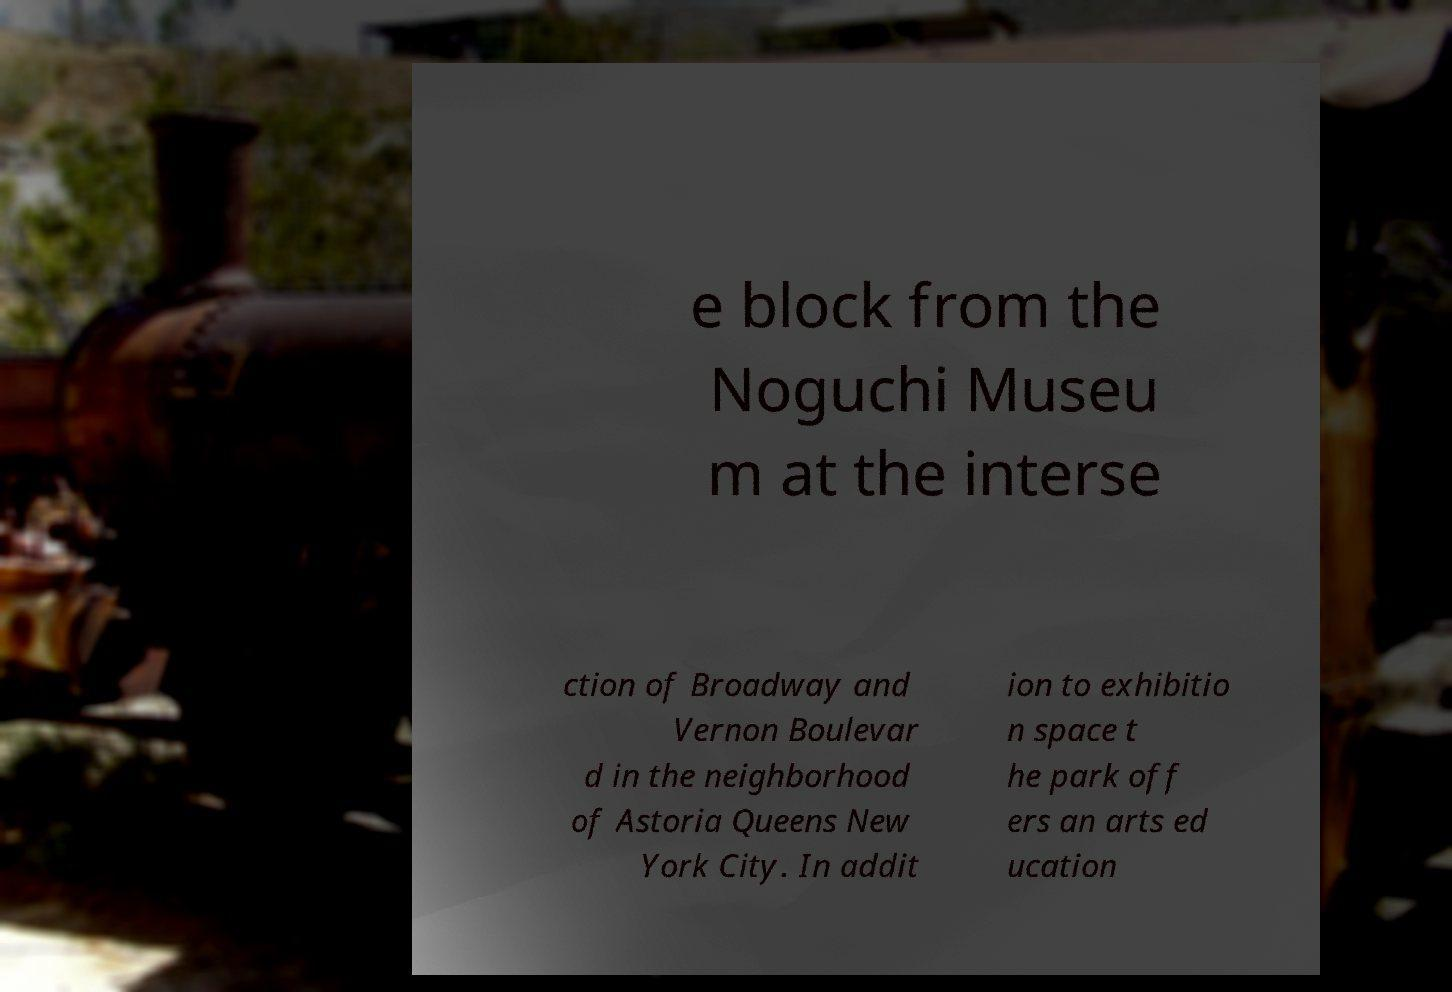Please identify and transcribe the text found in this image. e block from the Noguchi Museu m at the interse ction of Broadway and Vernon Boulevar d in the neighborhood of Astoria Queens New York City. In addit ion to exhibitio n space t he park off ers an arts ed ucation 